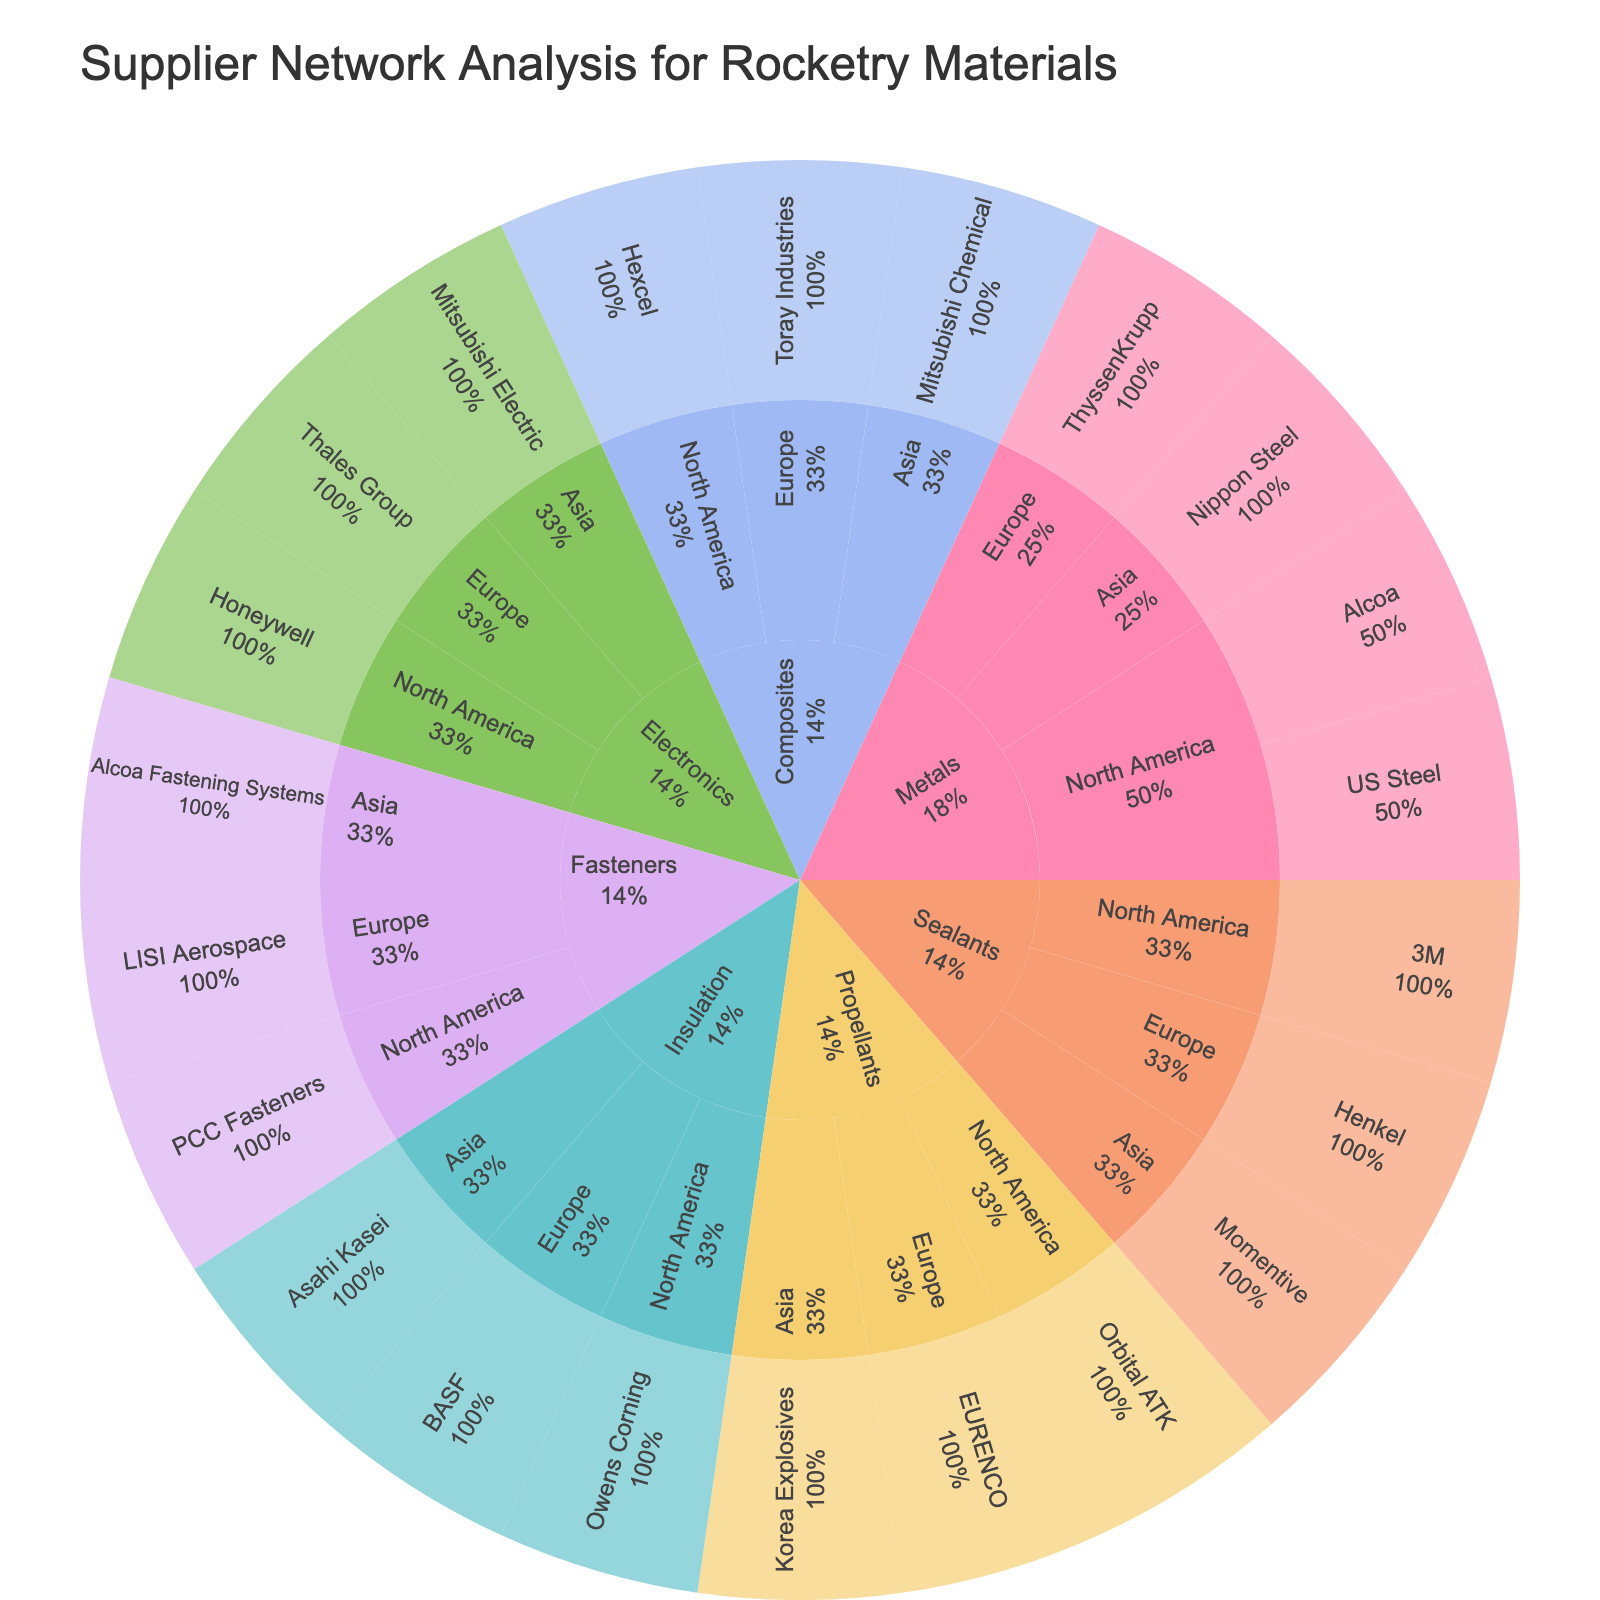What's the title of the plot? The title is displayed at the top of the plot and is usually straightforward to read. It summarizes the content and purpose of the plot.
Answer: Supplier Network Analysis for Rocketry Materials How many supplier locations are there for Metals? To find this, look at the 'Metals' section and count the distinct categories based on geographical regions (North America, Europe, Asia).
Answer: 3 Which supplier in North America provides Propellants? Identify the path starting from 'Propellants' and then drill down to 'North America'. The supplier name will be listed under this category.
Answer: Orbital ATK Are there more suppliers in Europe or Asia for Electronics? Examine the sections for 'Electronics' in both Europe and Asia and count the number of suppliers in each region. Compare these counts.
Answer: Europe Which material type has the most variety of suppliers? Check each top-level category (Material Type) and count the total number of unique suppliers associated with each. Identify the Material Type with the highest count.
Answer: Composites How many suppliers are there for Fasteners in total? Locate the 'Fasteners' section and count all the suppliers listed under it across all geographical locations.
Answer: 3 Which region has the largest number of unique suppliers? Go through each supplier location (North America, Europe, Asia), count the unique suppliers, and identify the region with the highest count.
Answer: North America Do Composites suppliers from Asia and Europe together outnumber those from North America? Count suppliers in each region separately. Compare the sum of suppliers from Asia and Europe against those from North America for Composites.
Answer: No How many suppliers are there for Insulation in Asia? Look under the 'Insulation' category and count the suppliers specifically listed under 'Asia'.
Answer: 1 Do any suppliers provide more than one type of material? Trace each supplier from the bottom tier of the sunburst plot to see if their path branches into multiple materials.
Answer: No 